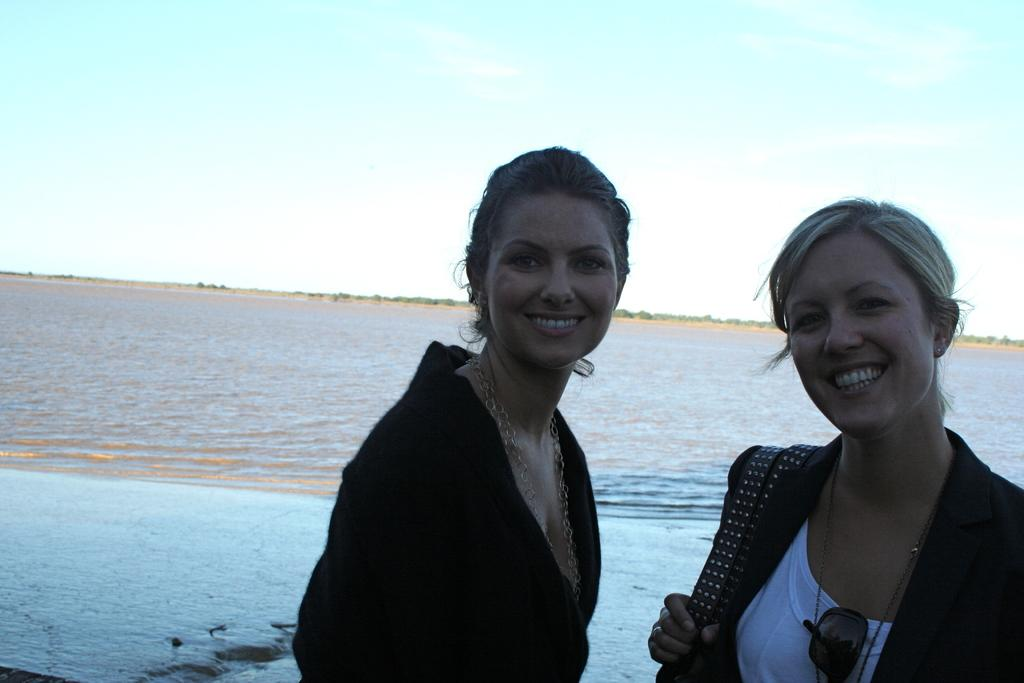How many people are in the image? There are two women in the image. What can be seen in the background of the image? There is water and clouds in the sky visible in the background of the image. What type of alarm can be heard going off in the image? There is no alarm present in the image, and therefore no sound can be heard. 